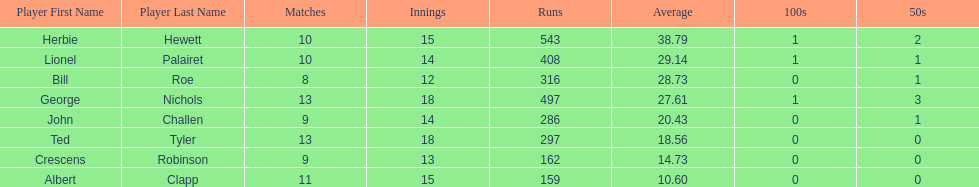Name a player that play in no more than 13 innings. Bill Roe. 